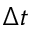Convert formula to latex. <formula><loc_0><loc_0><loc_500><loc_500>\Delta t</formula> 